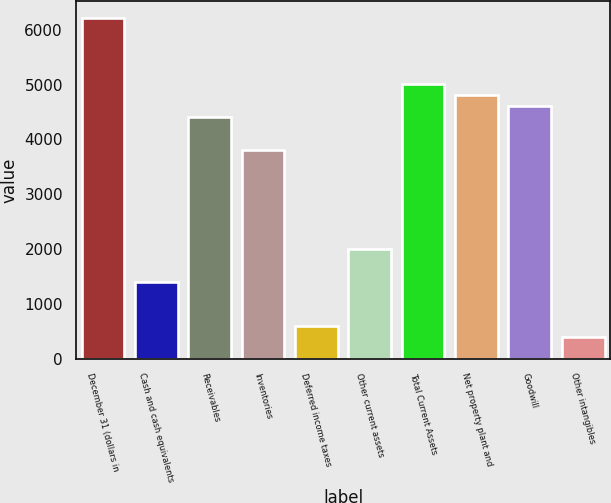<chart> <loc_0><loc_0><loc_500><loc_500><bar_chart><fcel>December 31 (dollars in<fcel>Cash and cash equivalents<fcel>Receivables<fcel>Inventories<fcel>Deferred income taxes<fcel>Other current assets<fcel>Total Current Assets<fcel>Net property plant and<fcel>Goodwill<fcel>Other intangibles<nl><fcel>6210.09<fcel>1403.13<fcel>4407.48<fcel>3806.61<fcel>601.97<fcel>2004<fcel>5008.35<fcel>4808.06<fcel>4607.77<fcel>401.68<nl></chart> 